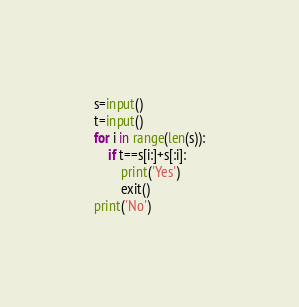Convert code to text. <code><loc_0><loc_0><loc_500><loc_500><_Python_>s=input()
t=input()
for i in range(len(s)):
    if t==s[i:]+s[:i]:
        print('Yes')
        exit()
print('No')
</code> 